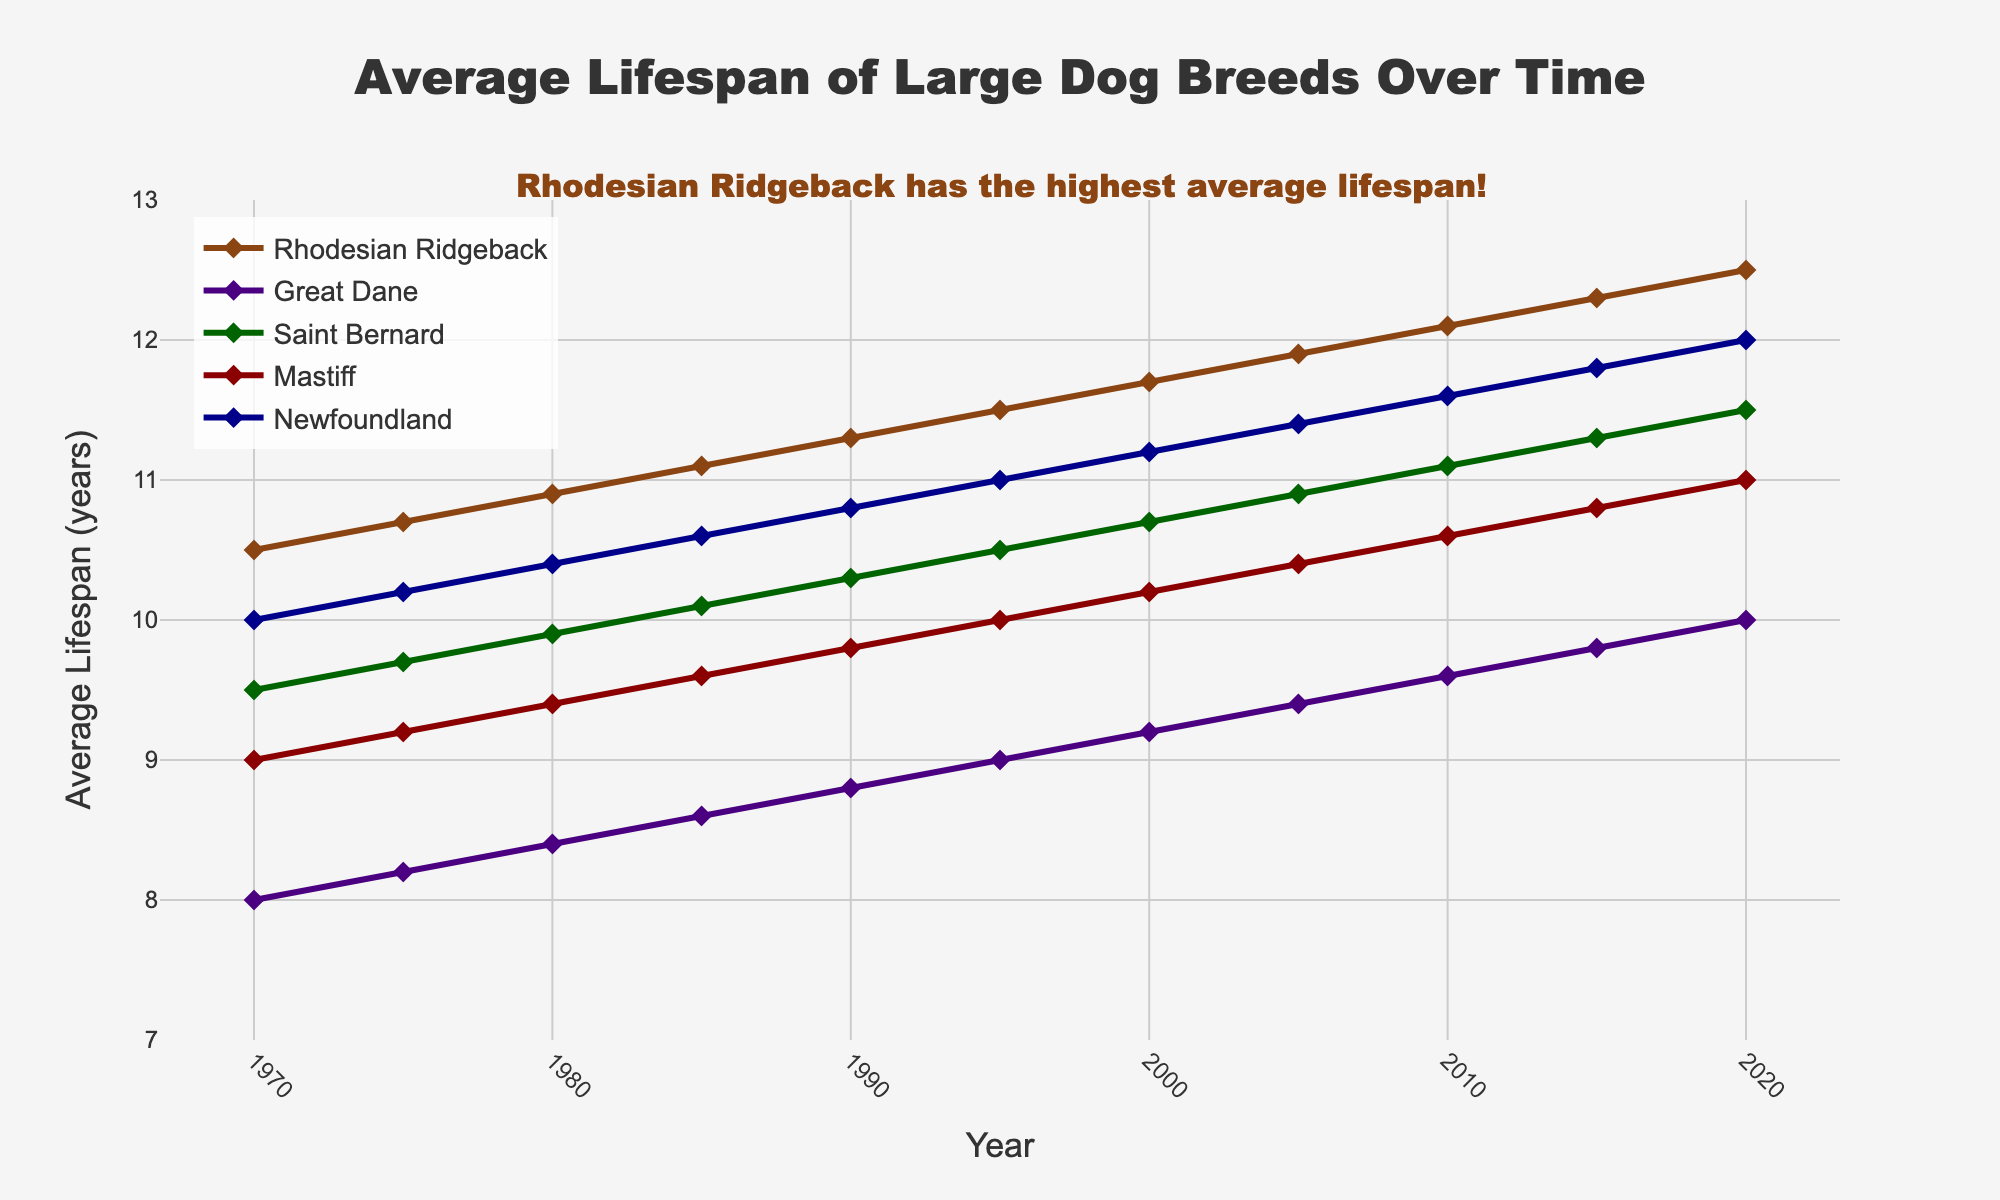What year did the Rhodesian Ridgeback first surpass an average lifespan of 12 years? The graphical line representing the Rhodesian Ridgeback lifespan shows a value above 12 years starting from the year 2010.
Answer: 2010 In 1985, which breed had the second highest average lifespan? Observing the chart for the year 1985 and comparing the heights of the lines, the second highest lifespan belongs to the Newfoundland, which is slightly lower than the Rhodesian Ridgeback.
Answer: Newfoundland What's the difference in average lifespan between the Great Dane and the Mastiff in 2020? For the year 2020, the Great Dane's average lifespan is 10.0 years and the Mastiff's is 11.0 years. Subtracting the Great Dane's lifespan from the Mastiff’s gives 11.0 - 10.0.
Answer: 1 year Which breed has shown the most increase in average lifespan from 1970 to 2020? Looking at the total height increase from 1970 to 2020 for each breed on the chart, the Rhodesian Ridgeback shows the most significant increase from 10.5 to 12.5 years.
Answer: Rhodesian Ridgeback In which year did every breed have an average lifespan of at least 9 years? Observing the chart, we can see that starting from 1995, all breeds have an average lifespan above 9 years.
Answer: 1995 How does the average lifespan of Saint Bernard compare to the Rhodesian Ridgeback in 2000? For the year 2000 on the chart, the Saint Bernard's average lifespan is 10.7 years while the Rhodesian Ridgeback's lifespan is 11.7 years, indicating that the Saint Bernard has a shorter lifespan by 1 year compared to the Rhodesian Ridgeback.
Answer: 1 year shorter What is the overall trend in the average lifespan of all breeds from 1970 to 2020? Observing all lines from 1970 to 2020, we can notice that every breed's average lifespan generally trends upwards over time, suggesting an overall increase.
Answer: Increasing Which breed had the lowest average lifespan in 1990 and what was it? In 1990, the graphical line for the Great Dane is at the lowest point compared to others with an approximate lifespan of 8.8 years.
Answer: Great Dane, 8.8 years Between 1985 and 1995, which breed showed the largest increase in lifespan? Comparing the increase in heights of lines from 1985 to 1995, the Newfoundland shows a rise from approximately 10.6 to 11.0 years, which is the largest among the breeds.
Answer: Newfoundland 